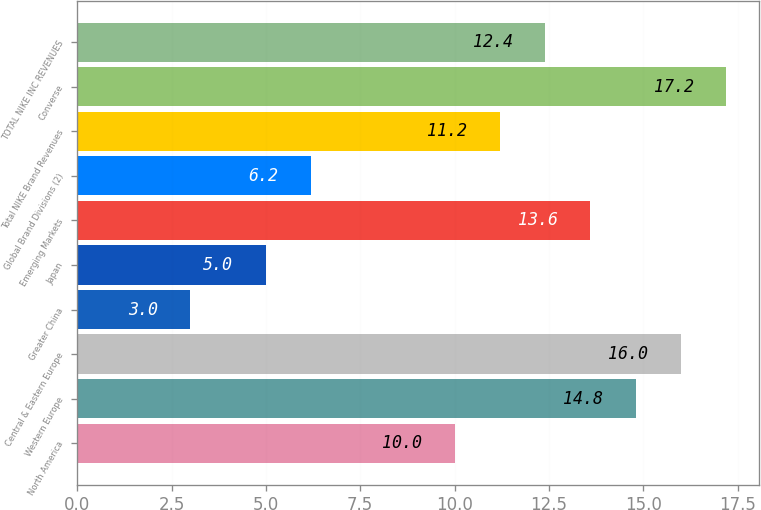Convert chart to OTSL. <chart><loc_0><loc_0><loc_500><loc_500><bar_chart><fcel>North America<fcel>Western Europe<fcel>Central & Eastern Europe<fcel>Greater China<fcel>Japan<fcel>Emerging Markets<fcel>Global Brand Divisions (2)<fcel>Total NIKE Brand Revenues<fcel>Converse<fcel>TOTAL NIKE INC REVENUES<nl><fcel>10<fcel>14.8<fcel>16<fcel>3<fcel>5<fcel>13.6<fcel>6.2<fcel>11.2<fcel>17.2<fcel>12.4<nl></chart> 